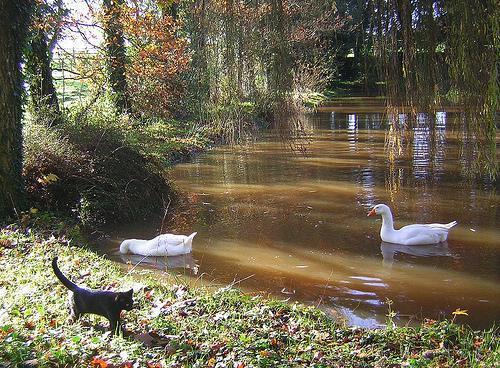How many geese are there?
Give a very brief answer. 2. 